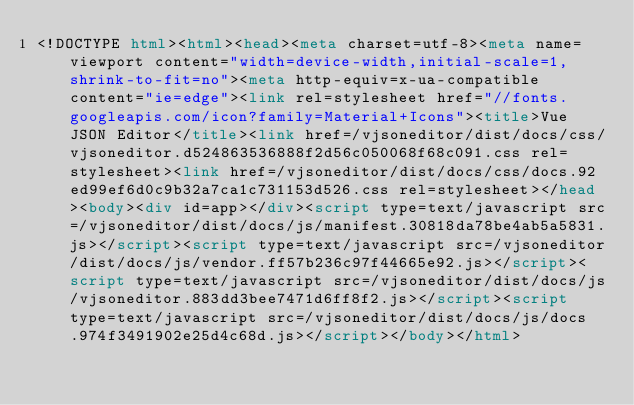<code> <loc_0><loc_0><loc_500><loc_500><_HTML_><!DOCTYPE html><html><head><meta charset=utf-8><meta name=viewport content="width=device-width,initial-scale=1,shrink-to-fit=no"><meta http-equiv=x-ua-compatible content="ie=edge"><link rel=stylesheet href="//fonts.googleapis.com/icon?family=Material+Icons"><title>Vue JSON Editor</title><link href=/vjsoneditor/dist/docs/css/vjsoneditor.d524863536888f2d56c050068f68c091.css rel=stylesheet><link href=/vjsoneditor/dist/docs/css/docs.92ed99ef6d0c9b32a7ca1c731153d526.css rel=stylesheet></head><body><div id=app></div><script type=text/javascript src=/vjsoneditor/dist/docs/js/manifest.30818da78be4ab5a5831.js></script><script type=text/javascript src=/vjsoneditor/dist/docs/js/vendor.ff57b236c97f44665e92.js></script><script type=text/javascript src=/vjsoneditor/dist/docs/js/vjsoneditor.883dd3bee7471d6ff8f2.js></script><script type=text/javascript src=/vjsoneditor/dist/docs/js/docs.974f3491902e25d4c68d.js></script></body></html></code> 